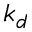Convert formula to latex. <formula><loc_0><loc_0><loc_500><loc_500>k _ { d }</formula> 